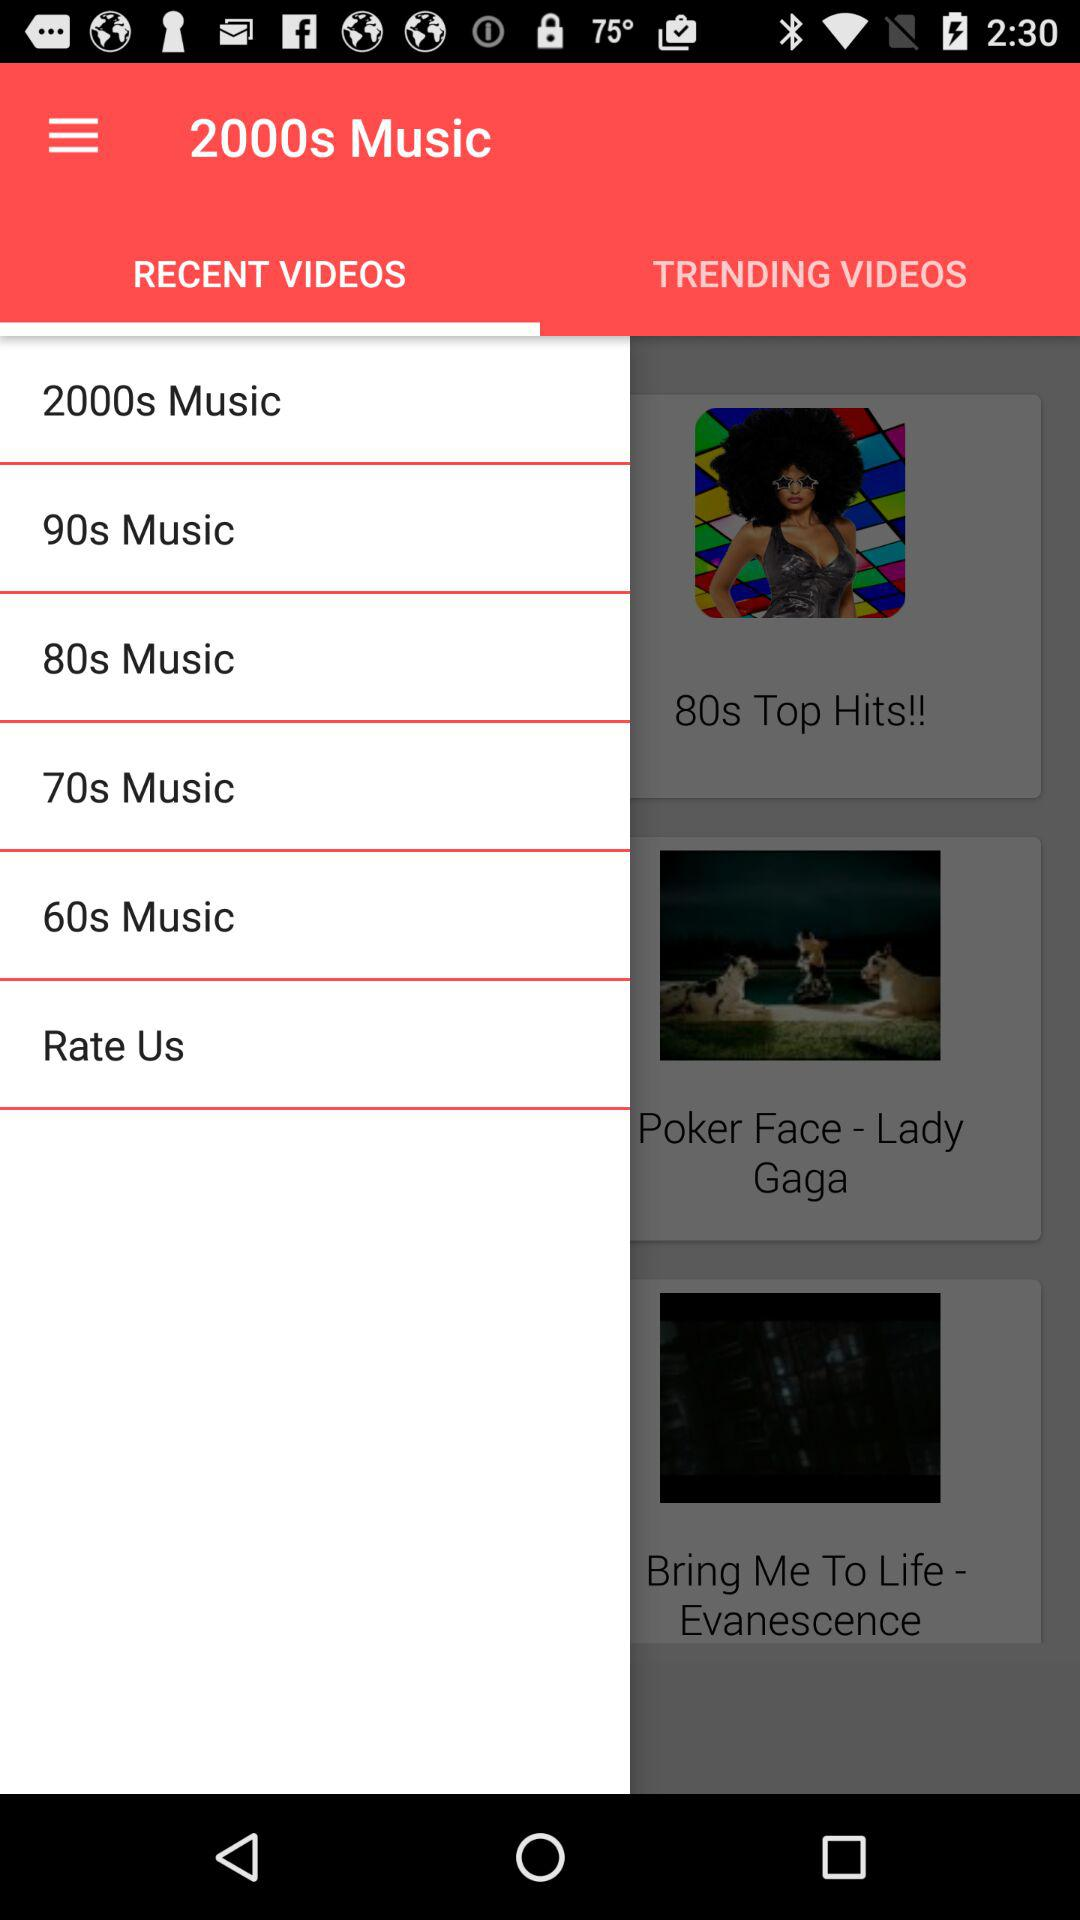What is the application name?
When the provided information is insufficient, respond with <no answer>. <no answer> 